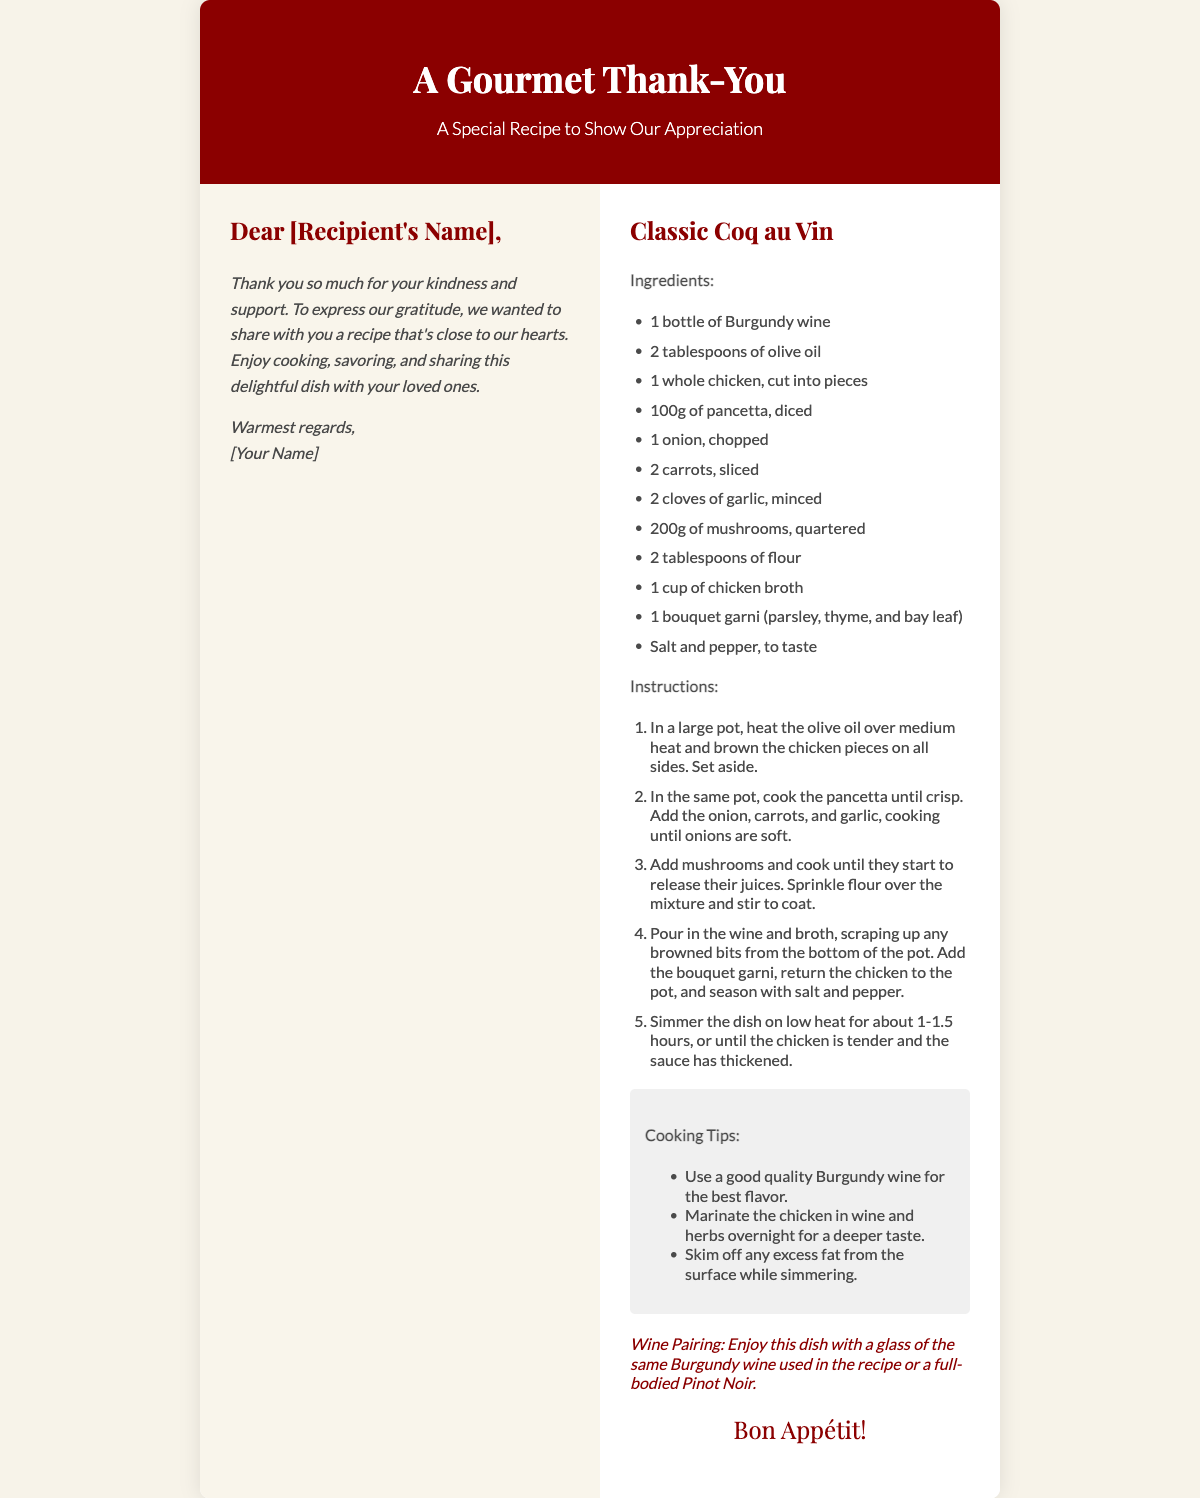What is the title of the card? The title of the card is prominently displayed in large font and serves as the main heading of the document.
Answer: A Gourmet Thank-You What dish is featured in the card? The dish is mentioned in a prominent header within the recipe section as a key focus of the card.
Answer: Classic Coq au Vin How many cloves of garlic are listed in the ingredients? The number of garlic cloves is specified in the ingredients section, providing clarity on the recipe's requirements.
Answer: 2 cloves What is one of the cooking tips mentioned? The cooking tips are listed in a dedicated section, providing helpful insights for preparing the dish.
Answer: Use a good quality Burgundy wine for the best flavor What wine is suggested for pairing? The suggested wine pairing is found in the wine pairing section, advising a suitable pairing for the dish.
Answer: Burgundy wine or a full-bodied Pinot Noir What is the closing phrase of the card? The closing phrase adds a personal touch and concludes the message, serving as a warm farewell.
Answer: Bon Appétit! How many ingredients are listed in total? The number of ingredients listed in the ingredients section provides a comprehensive view of what is needed for the recipe.
Answer: 11 What is included in the message to the recipient? The message section expresses appreciation and encourages the recipient to enjoy the recipe, indicating the card's purpose.
Answer: Thank you so much for your kindness and support How long should the dish simmer? The simmering time is specified in the instructions, guiding the cook on how to prepare the dish properly.
Answer: 1-1.5 hours 